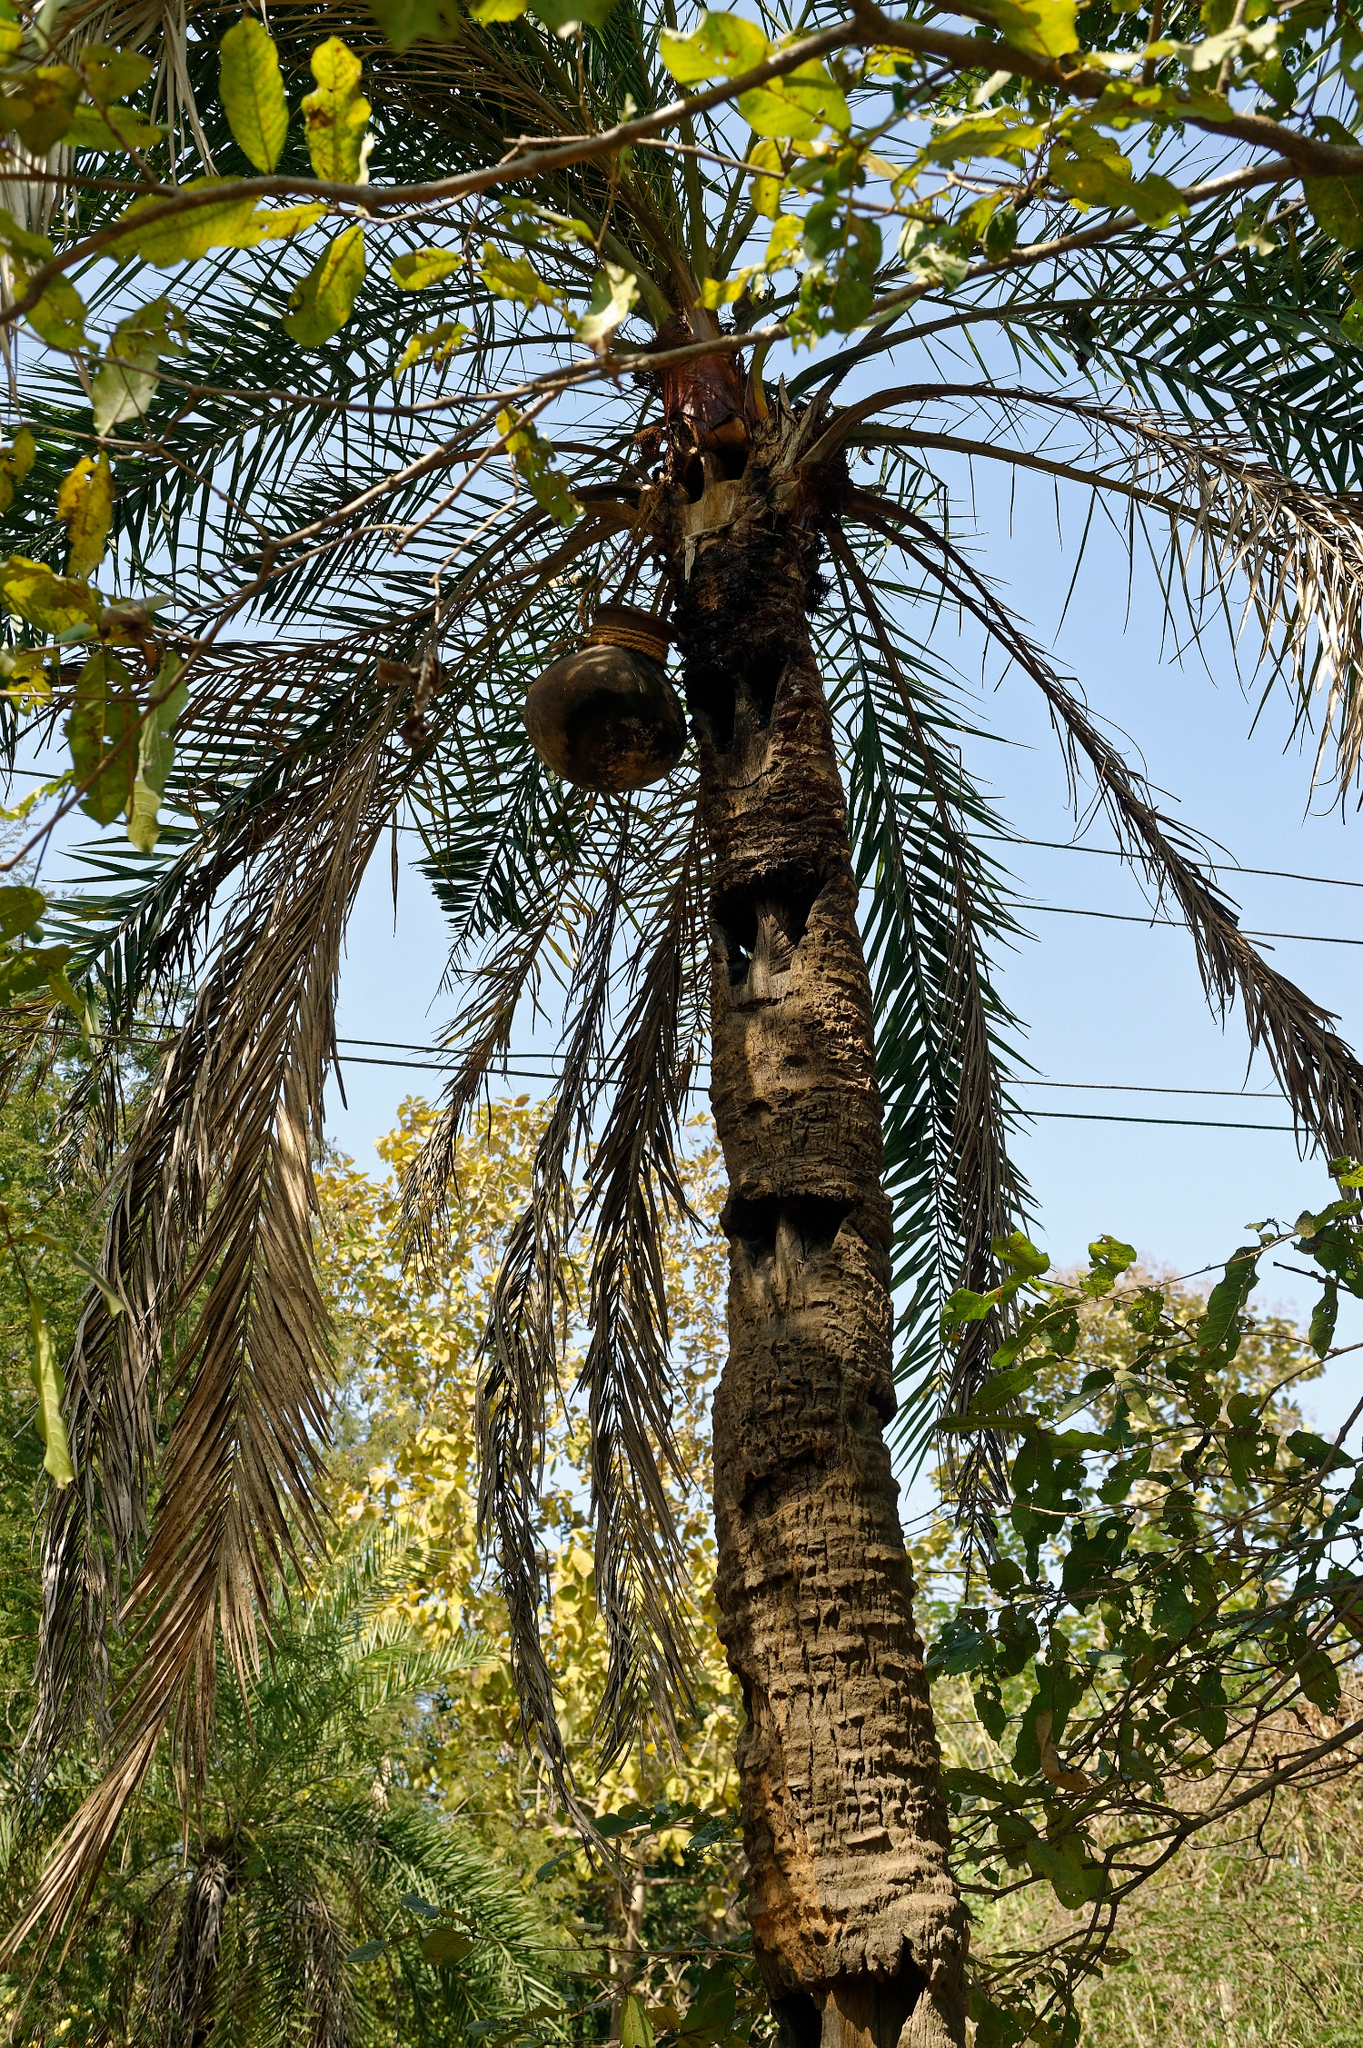Describe a day in the life of a bird living in this tree. In the dawn's first light, a bird nestled in the cozy birdhouse awakes to a symphony of forest sounds. The gentle rustle of palm fronds and the distant calls of other birds create a harmonious wake-up call. Stretching its wings, the bird steps out onto a branch and takes flight, soaring high above the trees. It spends the morning darting between branches, searching for breakfast: juicy insects and sweet fruits. By midday, the sun is high, and the bird rests in the cool shade of the palm's broad leaves, engaging in melodious chatter with its neighbors. As evening approaches, the sky turns into a canvas of orange and pink hues, prompting the bird to settle back into the birdhouse. There, amidst the gentle sway of the palm tree and the distant chirps of nocturnal creatures, the bird drifts off to sleep, ready to greet another day. What kind of adventures could a bird have while living in this tree? Living in this tree offers a bird countless adventures. One day, it might discover a hidden grove full of vibrant flowers buzzing with nectar right by the tree's roots. On another, it might join a flock of birds on a thrilling expedition across the forest, navigating canopies, dodging predators, and finding new food sources. During the rainy season, the bird might experience the exhilarating rush of flying through droplets of rain, feeling the cool mist on its wings. The bird could also make friends with a curious squirrel or witness the majestic flight of an eagle from the top of the palm. Every day brings new challenges and wonders, painting a life filled with excitement and discovery for the little avian adventurer. 